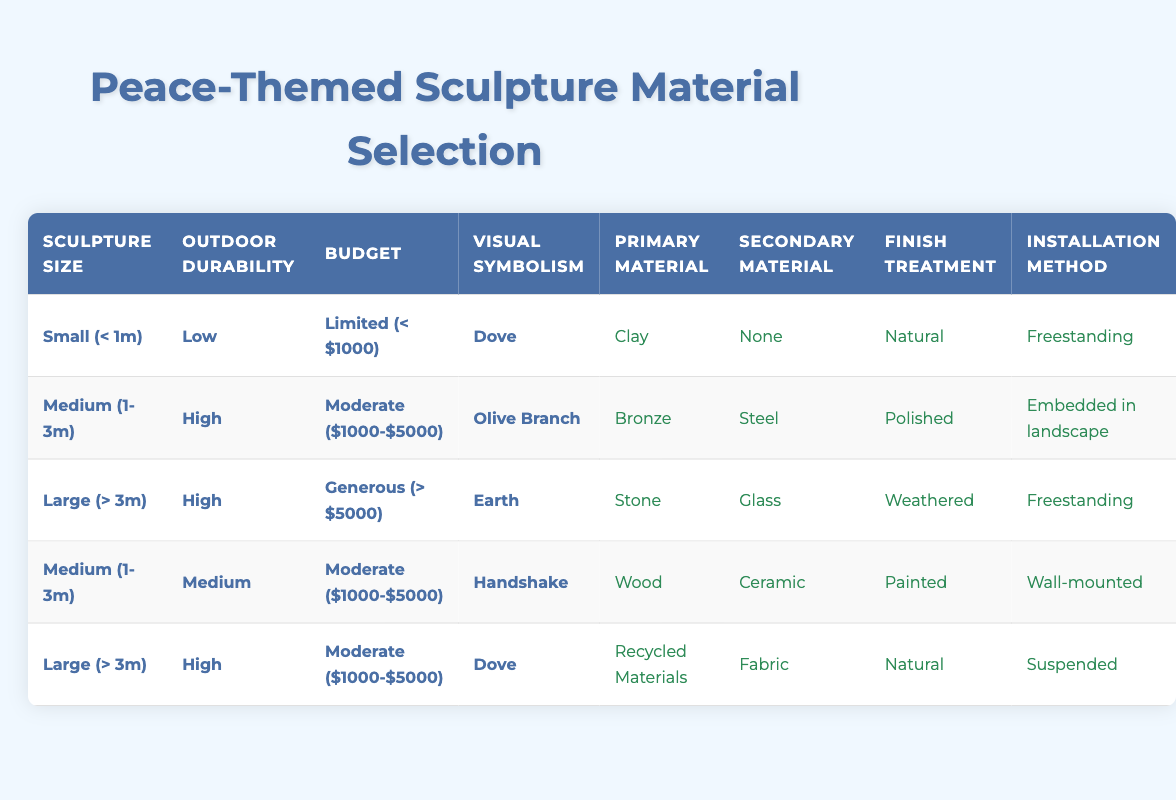What is the primary material used for small sculptures with low outdoor durability and a limited budget? The table shows that for a small sculpture with low outdoor durability and a limited budget, the primary material is clay.
Answer: Clay Which visual symbolism is associated with medium-sized sculptures that are high in outdoor durability and within a moderate budget? According to the table, medium-sized sculptures with high outdoor durability and a moderate budget symbolize an olive branch.
Answer: Olive Branch Are all large sculptures designed to be freestanding? By checking the table, two of the entries for large sculptures indicate they are freestanding, but one entry describes a large sculpture as suspended, so the answer is no.
Answer: No What is the secondary material used for large sculptures that symbolize a dove and have high outdoor durability with a moderate budget? The table specifies that for large sculptures symbolizing a dove with high outdoor durability and a moderate budget, the secondary material used is fabric.
Answer: Fabric What are the materials used for medium sculptures that symbolize a handshake? The table indicates that medium sculptures symbolizing a handshake use wood as the primary material and ceramic as the secondary material.
Answer: Wood, Ceramic For sculptures larger than 3 meters and with a generous budget, what installation method is proposed? In the table, the installation method for large sculptures exceeding 3 meters with a generous budget is freestanding.
Answer: Freestanding How many different primary materials can be used for medium-sized sculptures? Investigating the table, medium-sized sculptures can be made from bronze (when symbolizing an olive branch) and wood (when symbolizing a handshake), resulting in two distinct primary materials.
Answer: 2 Does the table provide a primary material option for small sculptures with high durability? From the table, there are no entries for small sculptures with high outdoor durability, only for low and medium levels. Thus, the answer is no.
Answer: No What is the finish treatment for structures that utilize bronze as the primary material? The table reveals that the finish treatment for medium sculptures made of bronze and symbolizing an olive branch is polished.
Answer: Polished 